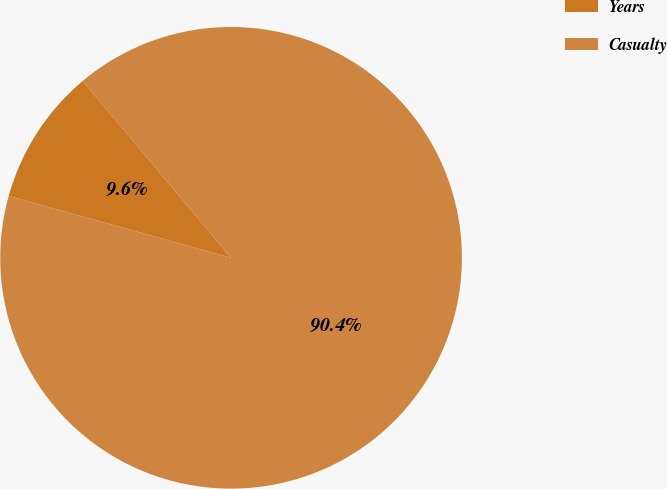<chart> <loc_0><loc_0><loc_500><loc_500><pie_chart><fcel>Years<fcel>Casualty<nl><fcel>9.57%<fcel>90.43%<nl></chart> 